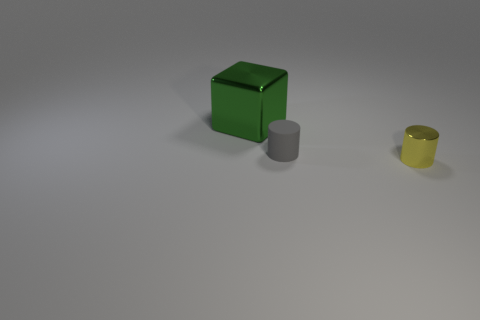Add 3 shiny things. How many objects exist? 6 Subtract all cubes. How many objects are left? 2 Add 1 cylinders. How many cylinders exist? 3 Subtract 0 gray blocks. How many objects are left? 3 Subtract all tiny rubber cylinders. Subtract all large green metallic things. How many objects are left? 1 Add 2 small gray rubber objects. How many small gray rubber objects are left? 3 